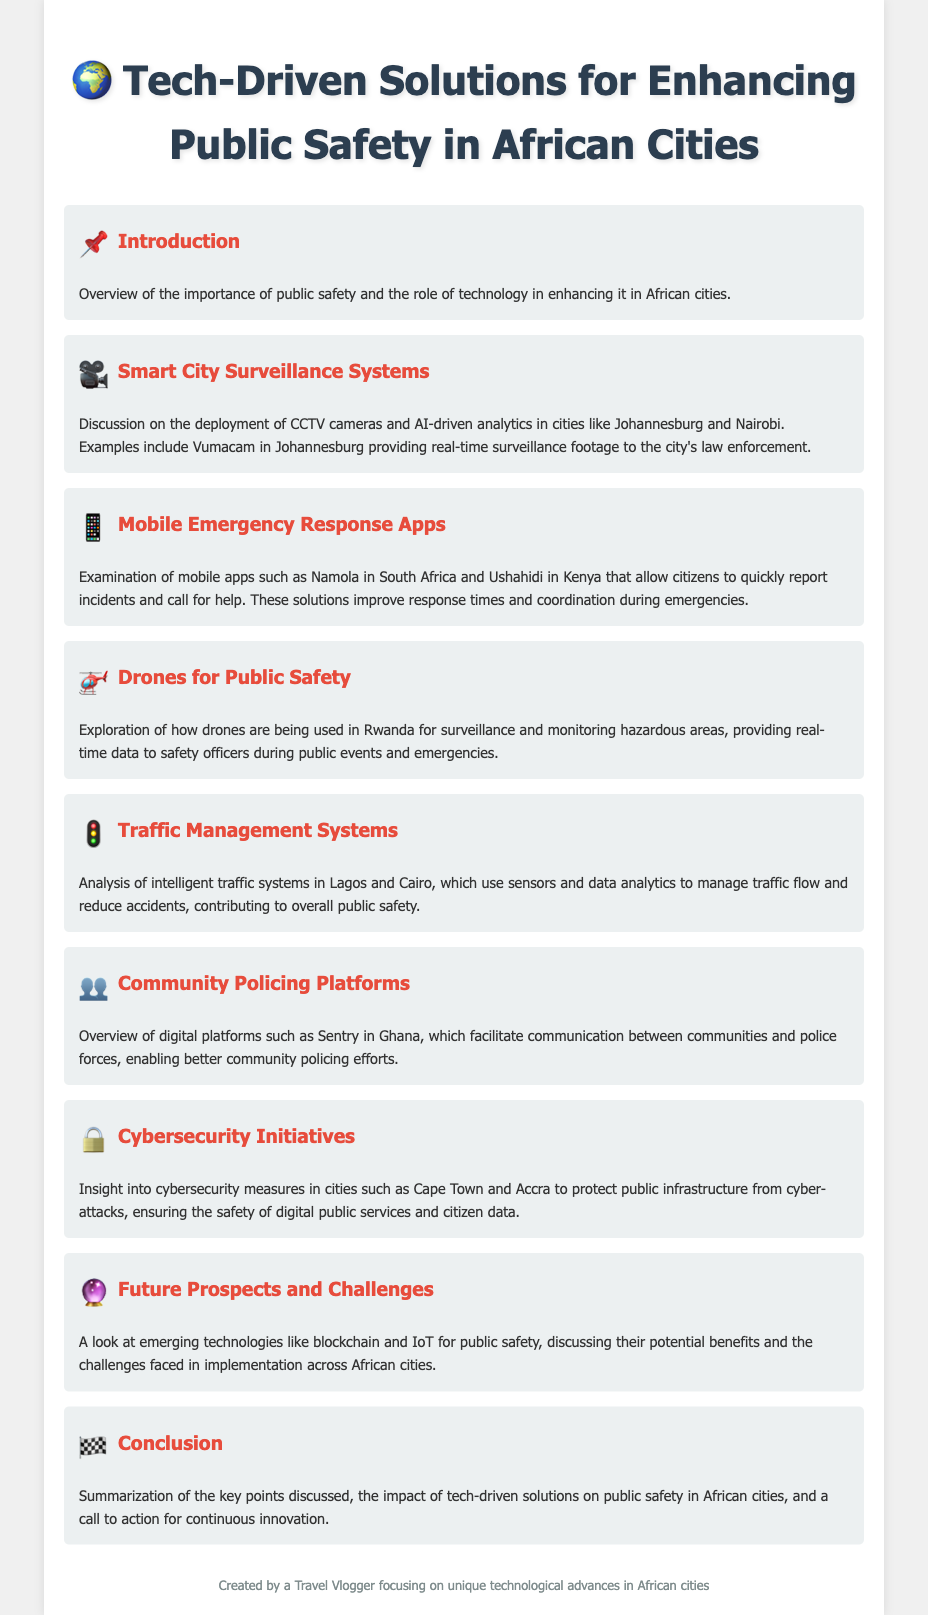what is the focus of the introduction? The introduction discusses the importance of public safety and the role of technology in enhancing it in African cities.
Answer: importance of public safety and technology which app is used in South Africa for emergency response? The document mentions Namola as the mobile app used in South Africa for emergency response.
Answer: Namola what technology is deployed in cities like Johannesburg and Nairobi? The document talks about Smart City Surveillance Systems being deployed in these cities.
Answer: Smart City Surveillance Systems how are drones utilized in Rwanda? Drones are used for surveillance and monitoring hazardous areas during public events and emergencies in Rwanda.
Answer: surveillance and monitoring what digital platform is mentioned for community policing in Ghana? The document mentions Sentry as the digital platform for community policing in Ghana.
Answer: Sentry which two cities are highlighted for traffic management systems? The document highlights Lagos and Cairo for their intelligent traffic management systems.
Answer: Lagos and Cairo what major challenge is discussed for future tech implementations in African cities? The text discusses challenges faced in the implementation of emerging technologies like blockchain and IoT in African cities.
Answer: challenges in implementation how does Cape Town enhance its cybersecurity? Cape Town implements cybersecurity measures to protect public infrastructure from cyber-attacks.
Answer: cybersecurity measures what is the primary goal of tech-driven solutions mentioned in the document? The solutions aim to enhance public safety in African cities.
Answer: enhance public safety 